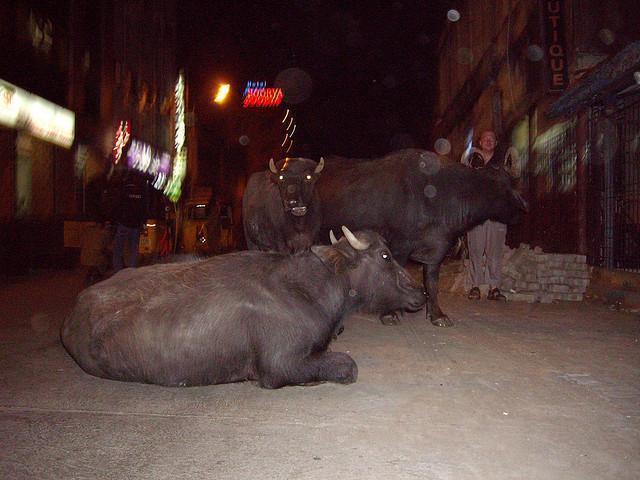Where is the animal currently sitting?
Make your selection from the four choices given to correctly answer the question.
Options: Street, park, boardwalk, beach. Street. 